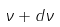<formula> <loc_0><loc_0><loc_500><loc_500>\nu + d \nu</formula> 